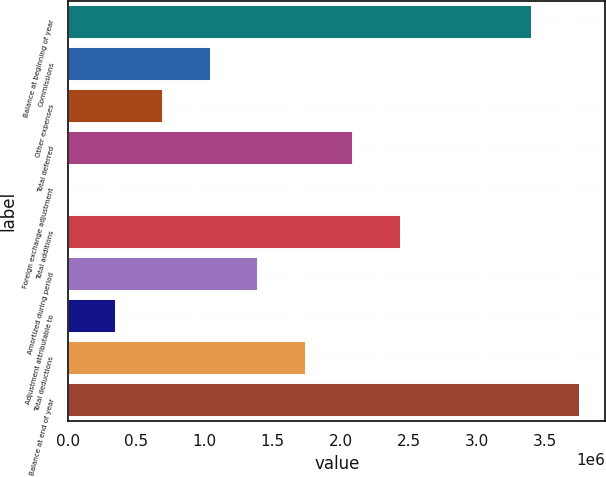Convert chart. <chart><loc_0><loc_0><loc_500><loc_500><bar_chart><fcel>Balance at beginning of year<fcel>Commissions<fcel>Other expenses<fcel>Total deferred<fcel>Foreign exchange adjustment<fcel>Total additions<fcel>Amortized during period<fcel>Adjustment attributable to<fcel>Total deductions<fcel>Balance at end of year<nl><fcel>3.40634e+06<fcel>1.04546e+06<fcel>696973<fcel>2.09091e+06<fcel>4.07<fcel>2.4394e+06<fcel>1.39394e+06<fcel>348489<fcel>1.74243e+06<fcel>3.75482e+06<nl></chart> 